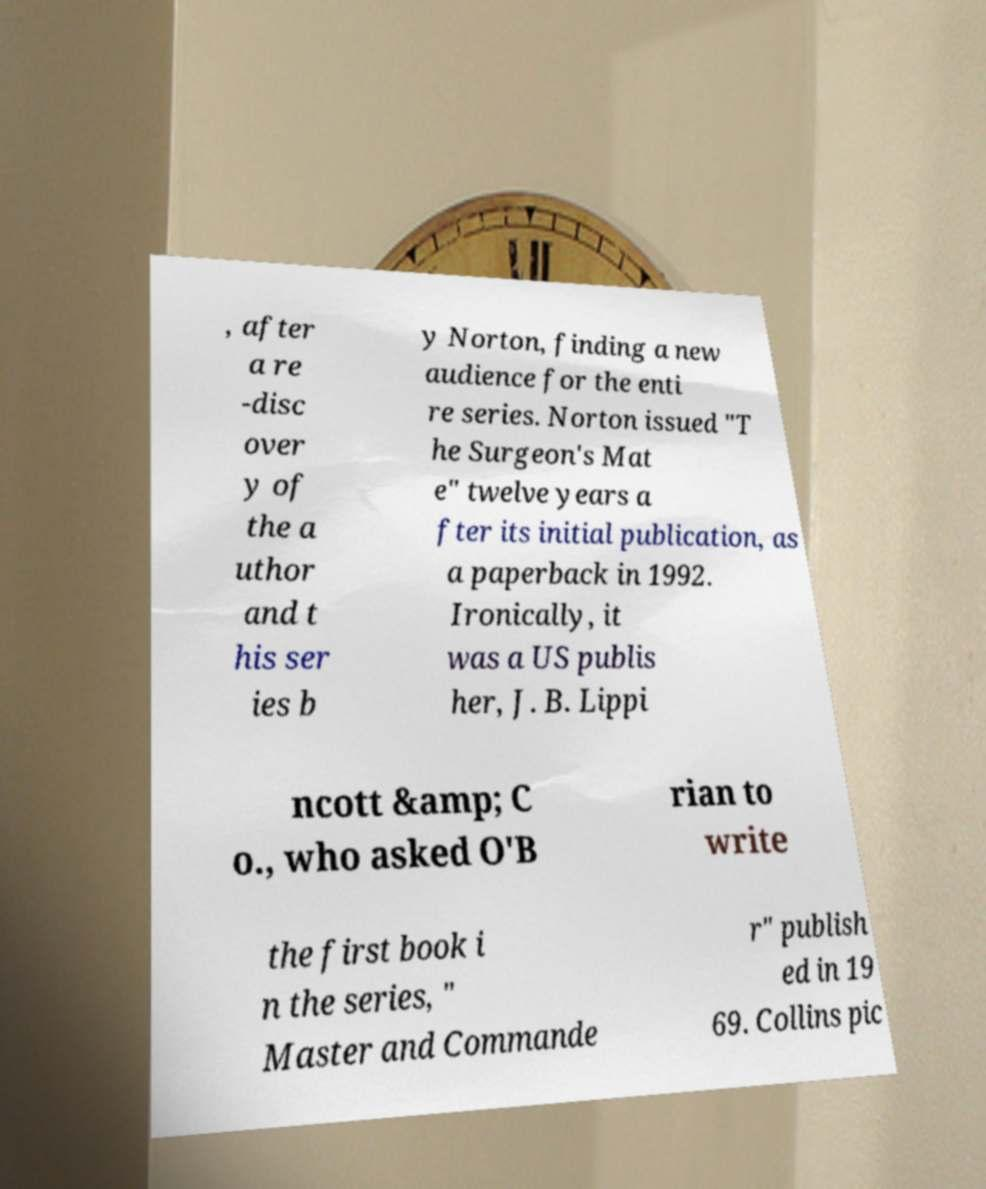What messages or text are displayed in this image? I need them in a readable, typed format. , after a re -disc over y of the a uthor and t his ser ies b y Norton, finding a new audience for the enti re series. Norton issued "T he Surgeon's Mat e" twelve years a fter its initial publication, as a paperback in 1992. Ironically, it was a US publis her, J. B. Lippi ncott &amp; C o., who asked O'B rian to write the first book i n the series, " Master and Commande r" publish ed in 19 69. Collins pic 